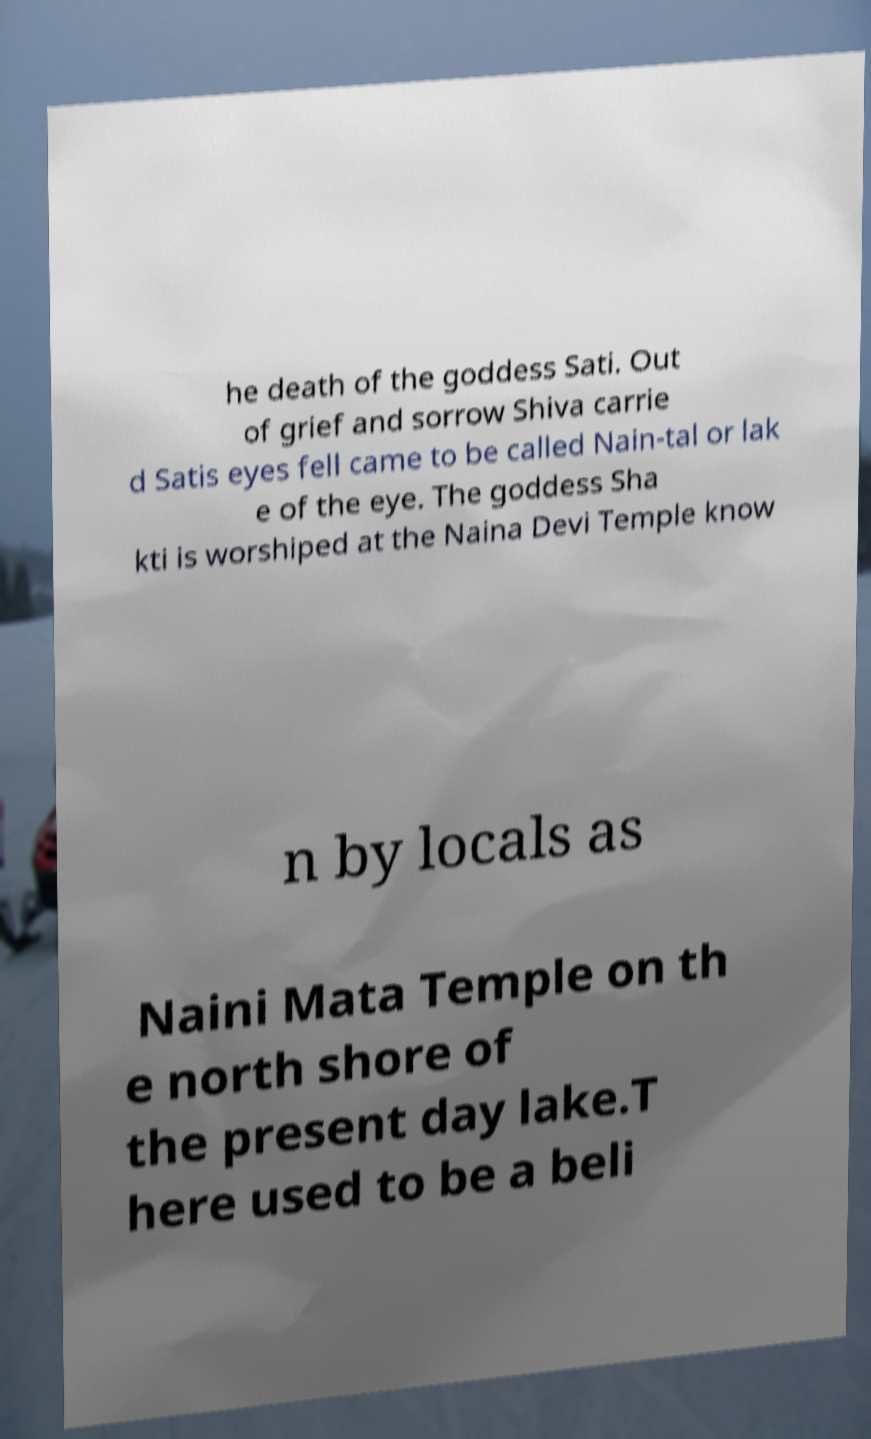Can you read and provide the text displayed in the image?This photo seems to have some interesting text. Can you extract and type it out for me? he death of the goddess Sati. Out of grief and sorrow Shiva carrie d Satis eyes fell came to be called Nain-tal or lak e of the eye. The goddess Sha kti is worshiped at the Naina Devi Temple know n by locals as Naini Mata Temple on th e north shore of the present day lake.T here used to be a beli 